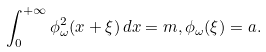<formula> <loc_0><loc_0><loc_500><loc_500>\int _ { 0 } ^ { + \infty } \phi ^ { 2 } _ { \omega } ( x + \xi ) \, d x = m , \phi _ { \omega } ( \xi ) = a .</formula> 